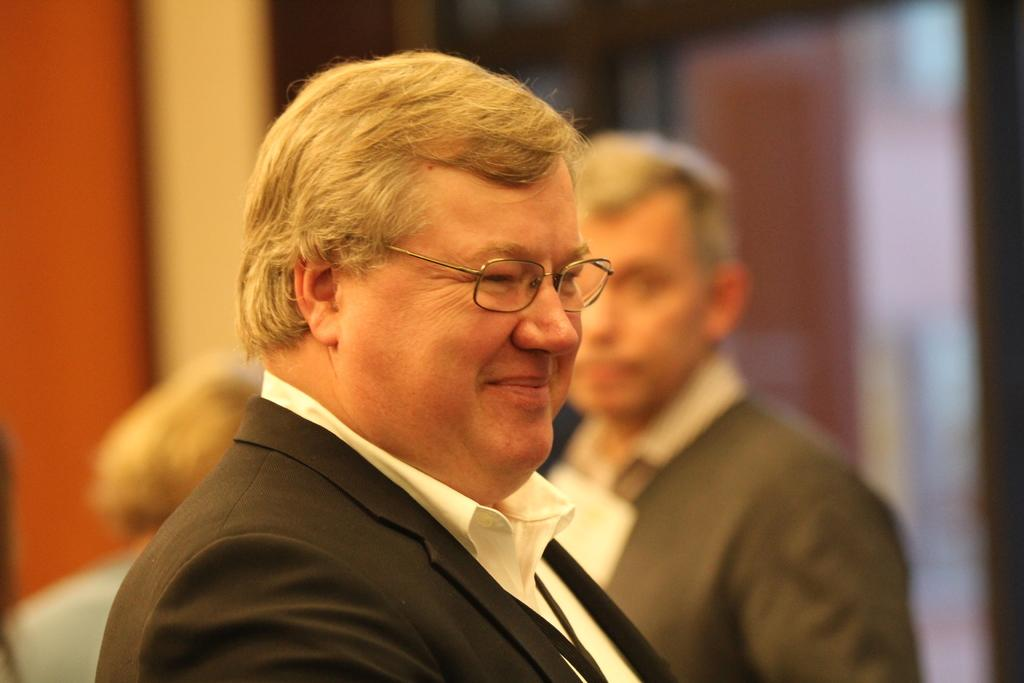Who is the main subject in the image? There is a person in the front of the image. What is the person doing in the image? The person is smiling. What accessory is the person wearing in the image? The person is wearing spectacles. What can be observed about the background of the image? The background of the image is blurry. Are there any other people visible in the image? Yes, there are people in the background of the image. What type of neck is the cow wearing in the image? There is no cow or neck present in the image. Is the writer visible in the image? There is no mention of a writer in the provided facts, and therefore it cannot be determined if the writer is visible in the image. 